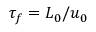Convert formula to latex. <formula><loc_0><loc_0><loc_500><loc_500>\tau _ { f } = L _ { 0 } / u _ { 0 }</formula> 